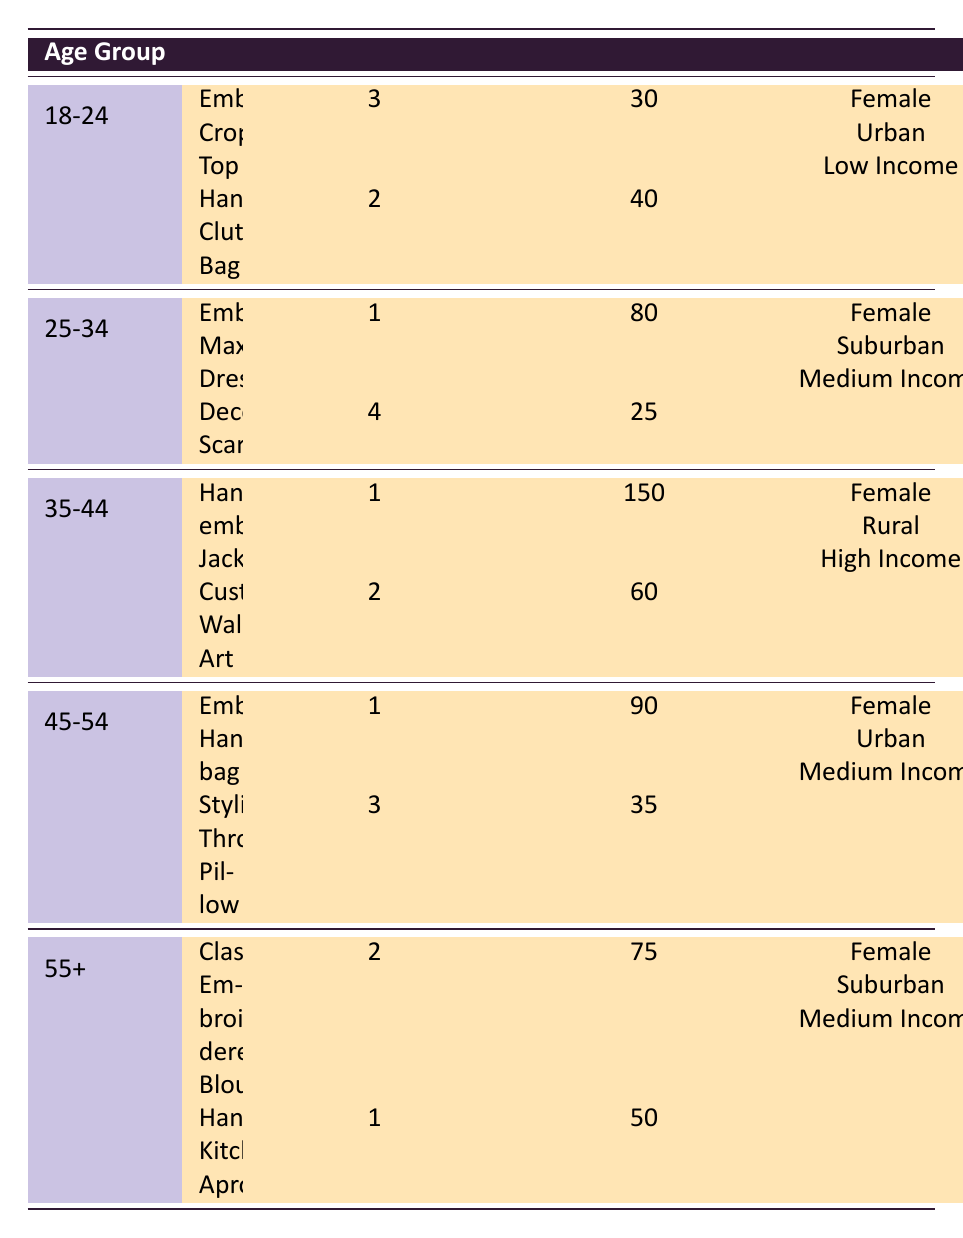What is the most frequently purchased item by customers aged 18-24? The table shows the purchase frequencies for the items bought by customers in the 18-24 age group. The "Embroidered Crop Top" has a purchase frequency of 3, which is higher than any other item in this age group.
Answer: Embroidered Crop Top Which item has the highest average spending among customers aged 35-44? In the 35-44 age group, there are two items: the "Hand-embroidered Jacket" with an average spending of 150 and "Customizable Wall Art" with 60. The highest is 150.
Answer: Hand-embroidered Jacket How many items did customers aged 45-54 purchase in total? In the 45-54 age group, there are two items: "Embroidered Handbag" (1 purchase) and "Stylish Throw Pillow" (3 purchases). The total is 1 + 3 = 4.
Answer: 4 Are all items purchased by customers aged 55 and older within the same income level? The items sold to customers aged 55+ include "Classic Embroidered Blouse" and "Handcrafted Kitchen Apron," both having a medium income level. Therefore, the answer is yes.
Answer: Yes What is the average spending for items bought by customers aged 25-34? The average spending can be calculated by adding the average spending for both items: 80 (Embroidered Maxi Dress) and 25 (Decorative Scarf), then dividing by 2: (80 + 25) / 2 = 52.5.
Answer: 52.5 Which age group has the highest average spending per item? To find this, calculate the average spending for each age group: 18-24 (35), 25-34 (52.5), 35-44 (105), 45-54 (62.5), and 55+ (62.5). The highest is in the 35-44 age group with 105.
Answer: 35-44 What is the sum of the purchase frequencies for all items purchased by customers aged 25-34? The items for this age group include "Embroidered Maxi Dress" (1) and "Decorative Scarf" (4), leading to a total frequency of 1 + 4 = 5.
Answer: 5 Are all customers categorized as high income purchasing a hand-embroidered item? The table shows that the only item under high income (35-44 group) is "Hand-embroidered Jacket." Therefore, the answer is yes, all items are embroidered.
Answer: Yes What is the total average spending across all age groups for the item "Stylish Throw Pillow"? The item is only listed under the age group 45-54 with an average spending of 35. Hence, its total average spending across those who bought it is also 35.
Answer: 35 